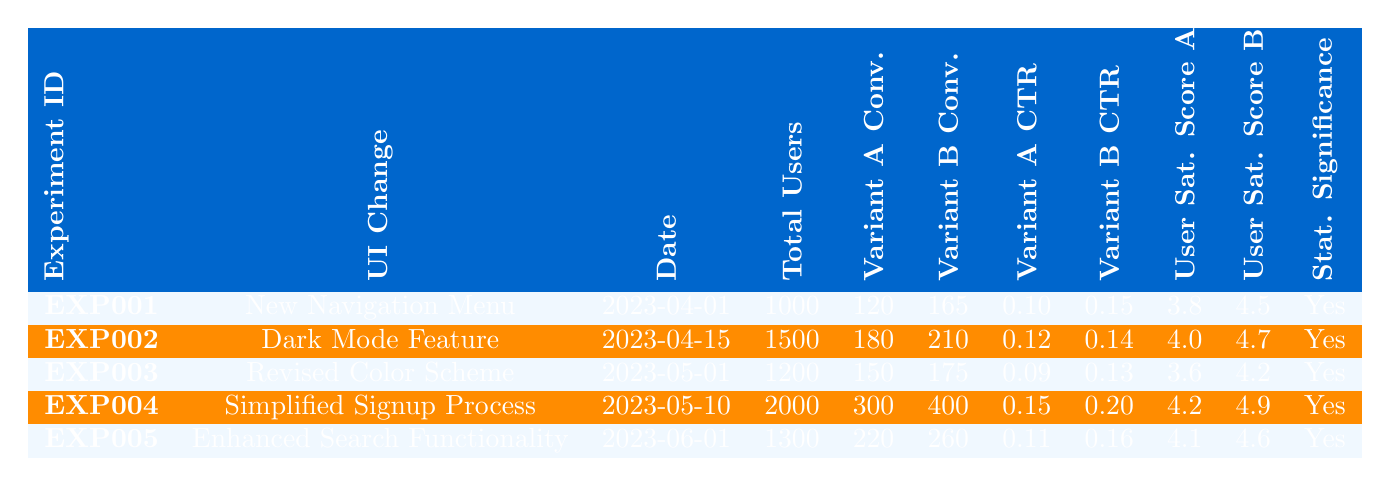What is the date of the "Enhanced Search Functionality" experiment? By locating the row corresponding to "Enhanced Search Functionality" under the UI Change column, I can see that the date specified for the experiment is 2023-06-01.
Answer: 2023-06-01 Which UI change had the highest user satisfaction score for variant B? Reviewing the User Satisfaction Score B column, I find that "Simplified Signup Process" has the highest score of 4.9 compared to others (4.5, 4.7, 4.2, and 4.6).
Answer: Simplified Signup Process What is the conversion rate for Variant A in the "Revised Color Scheme" experiment? In the "Revised Color Scheme" row, the Variant A Conversions is 150. To find the conversion rate, I take this figure and divide it by the Total Users (1200), which gives 150/1200 = 0.125 or 12.5%.
Answer: 0.125 How many total conversions were recorded across all experiments for Variant B? I add the conversions for Variant B from each experiment: 165 + 210 + 175 + 400 + 260 = 1210. This is the total number of conversions for Variant B.
Answer: 1210 Did the "Dark Mode Feature" experiment show statistical significance? Yes, under the Statistical Significance column for the "Dark Mode Feature" row, it states "Yes".
Answer: Yes Which variant had a higher click-through rate, Variant A or Variant B, in the "Simplified Signup Process" experiment? In the row for "Simplified Signup Process", the click-through rates are 0.15 for Variant A and 0.20 for Variant B. Since 0.20 is greater, Variant B performed better.
Answer: Variant B What was the average user satisfaction score for Variant A across all experiments? To find the average, I add up the User Satisfaction Scores for Variant A: 3.8 + 4.0 + 3.6 + 4.2 + 4.1 = 19.7, and divide by 5 (the number of experiments): 19.7 / 5 = 3.94.
Answer: 3.94 Which experiment recorded the highest number of total users? By reviewing the Total Users column, I note that "Simplified Signup Process" has the highest total with 2000 users compared to others.
Answer: Simplified Signup Process How many conversions for Variant A were recorded in total across all experiments? I sum the conversions for Variant A: 120 + 180 + 150 + 300 + 220 = 970. This reflects the total number of conversions for Variant A.
Answer: 970 Is the click-through rate for Variant A in the "Enhanced Search Functionality" higher than 0.12? In the row for "Enhanced Search Functionality", the click-through rate for Variant A is 0.11, which is not higher than 0.12.
Answer: No What is the difference in user satisfaction scores between Variant A and Variant B for the "New Navigation Menu"? For the "New Navigation Menu", the user satisfaction scores are 3.8 for Variant A and 4.5 for Variant B. The difference is calculated as 4.5 - 3.8 = 0.7.
Answer: 0.7 